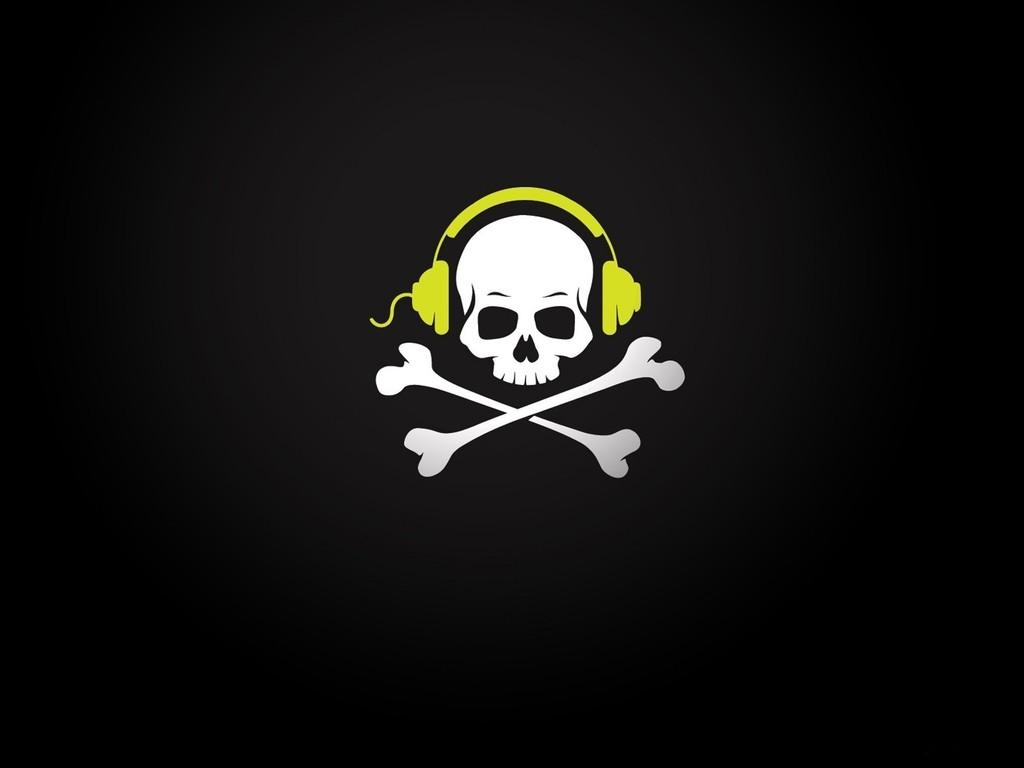What is the main subject of the image? The main subject of the image is a skull. What is placed around the skull? There is a headset around the skull. What other bones are visible in the image? There are two bones under the skull. What color is the background of the image? The background of the image is black. Where is the maid in the image? There is no maid present in the image. What type of mask is covering the skull in the image? There is no mask covering the skull in the image; it is a headset. 